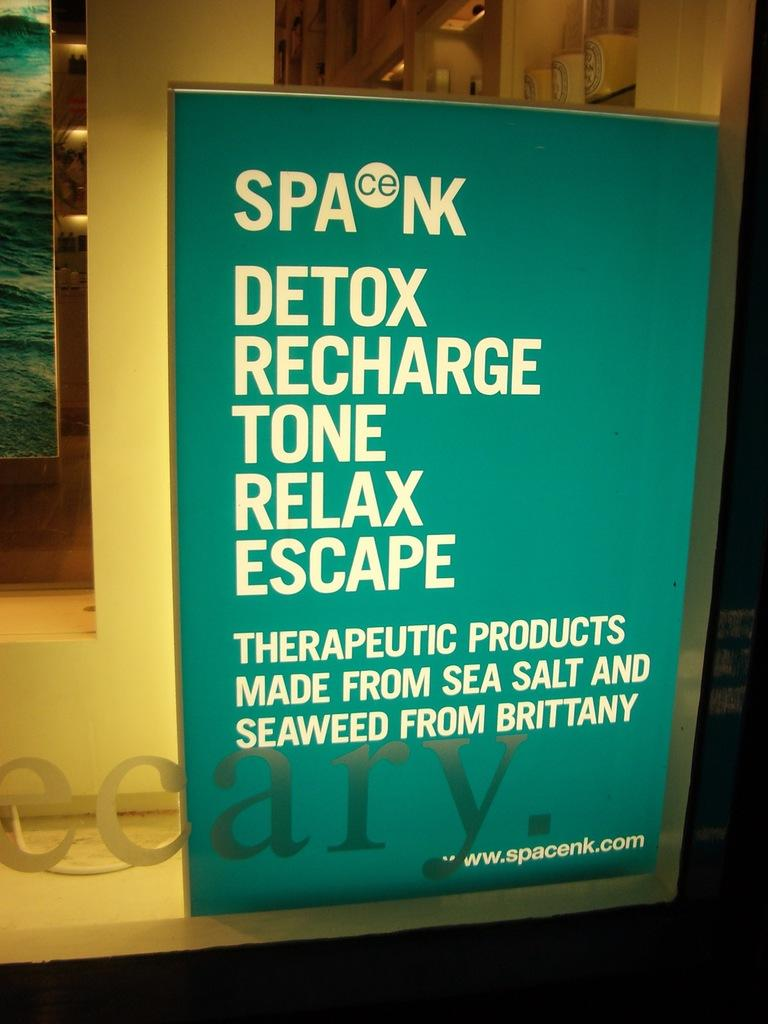<image>
Offer a succinct explanation of the picture presented. an advertisement for therapeutic products made from sea salt is on a window 